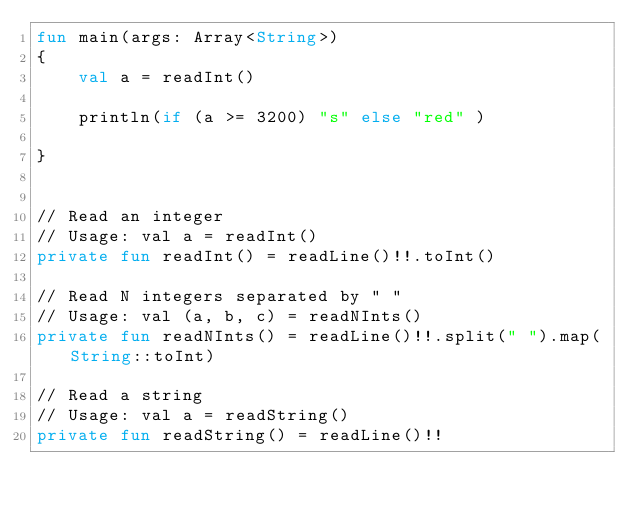Convert code to text. <code><loc_0><loc_0><loc_500><loc_500><_Kotlin_>fun main(args: Array<String>)
{
    val a = readInt()

    println(if (a >= 3200) "s" else "red" )

}


// Read an integer
// Usage: val a = readInt()
private fun readInt() = readLine()!!.toInt()

// Read N integers separated by " "
// Usage: val (a, b, c) = readNInts()
private fun readNInts() = readLine()!!.split(" ").map(String::toInt)

// Read a string
// Usage: val a = readString()
private fun readString() = readLine()!!
</code> 